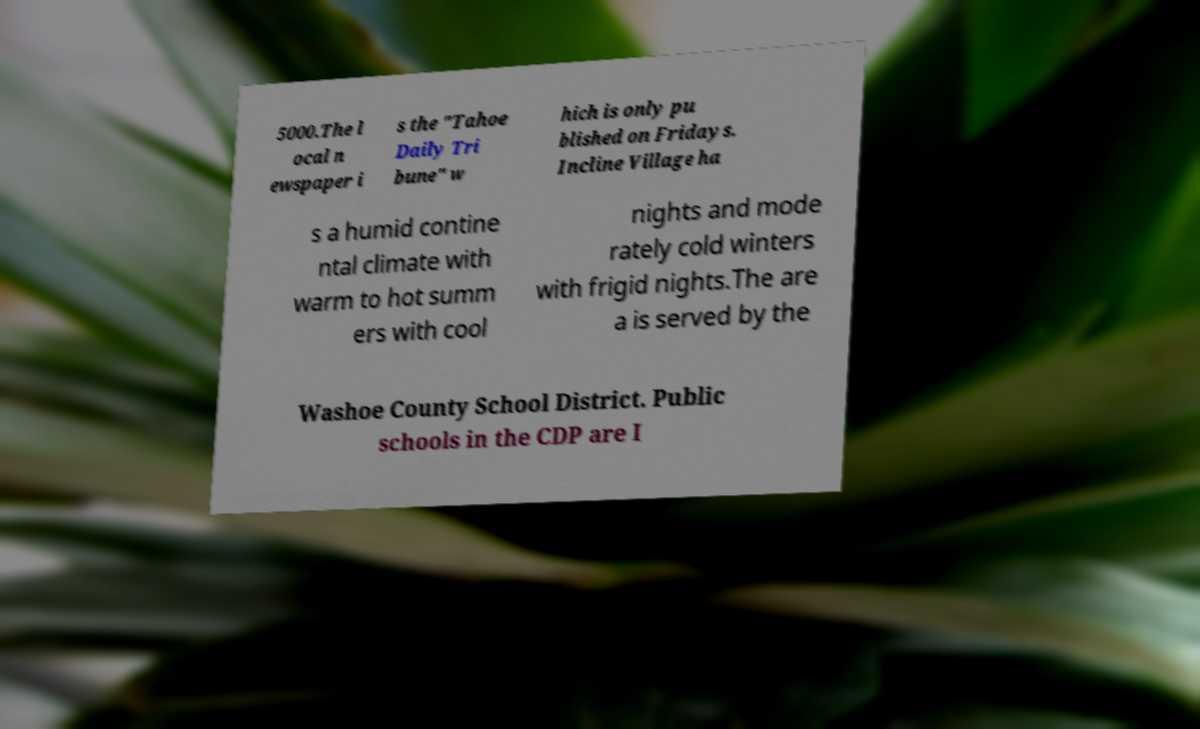There's text embedded in this image that I need extracted. Can you transcribe it verbatim? 5000.The l ocal n ewspaper i s the "Tahoe Daily Tri bune" w hich is only pu blished on Fridays. Incline Village ha s a humid contine ntal climate with warm to hot summ ers with cool nights and mode rately cold winters with frigid nights.The are a is served by the Washoe County School District. Public schools in the CDP are I 